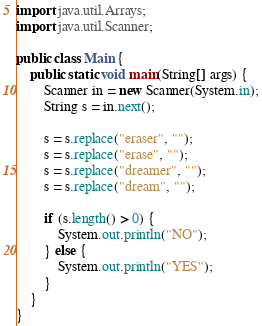<code> <loc_0><loc_0><loc_500><loc_500><_Java_>import java.util.Arrays;
import java.util.Scanner;

public class Main {
    public static void main(String[] args) {
        Scanner in = new Scanner(System.in);
        String s = in.next();

        s = s.replace("eraser", "");
        s = s.replace("erase", "");
        s = s.replace("dreamer", "");
        s = s.replace("dream", "");

        if (s.length() > 0) {
            System.out.println("NO");
        } else {
            System.out.println("YES");
        }
    }
}
</code> 